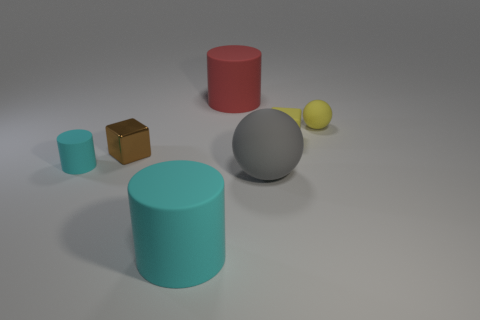The thing that is the same color as the small ball is what size?
Offer a terse response. Small. Do the large cylinder in front of the gray matte sphere and the small cylinder have the same color?
Offer a very short reply. Yes. Is there a small block of the same color as the small sphere?
Offer a terse response. Yes. Is there a tiny gray thing?
Make the answer very short. No. There is a small yellow object that is the same material as the yellow ball; what is its shape?
Your response must be concise. Cube. Is the shape of the big cyan thing the same as the cyan object behind the gray rubber sphere?
Offer a very short reply. Yes. What is the material of the cyan thing that is behind the cyan cylinder that is right of the tiny cyan object?
Your answer should be very brief. Rubber. How many other things are there of the same shape as the big gray object?
Ensure brevity in your answer.  1. There is a thing that is in front of the gray thing; does it have the same shape as the big thing behind the yellow matte sphere?
Provide a short and direct response. Yes. Are there any other things that are made of the same material as the brown object?
Ensure brevity in your answer.  No. 